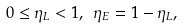<formula> <loc_0><loc_0><loc_500><loc_500>0 \leq \eta _ { L } < 1 , \ \eta _ { E } = { 1 - \eta _ { L } } ,</formula> 